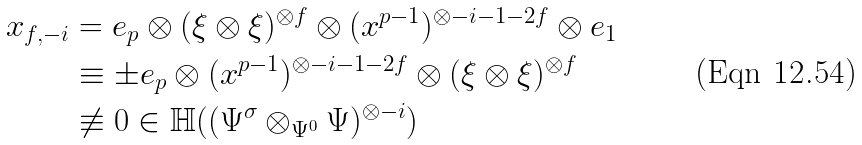<formula> <loc_0><loc_0><loc_500><loc_500>\ x _ { f , - i } & = e _ { p } \otimes ( \xi \otimes \xi ) ^ { \otimes f } \otimes ( x ^ { p - 1 } ) ^ { \otimes - i - 1 - 2 f } \otimes e _ { 1 } \\ & \equiv \pm e _ { p } \otimes ( x ^ { p - 1 } ) ^ { \otimes - i - 1 - 2 f } \otimes ( \xi \otimes \xi ) ^ { \otimes f } \\ & \not \equiv 0 \in \mathbb { H } ( ( \Psi ^ { \sigma } \otimes _ { \Psi ^ { 0 } } \Psi ) ^ { \otimes - i } )</formula> 